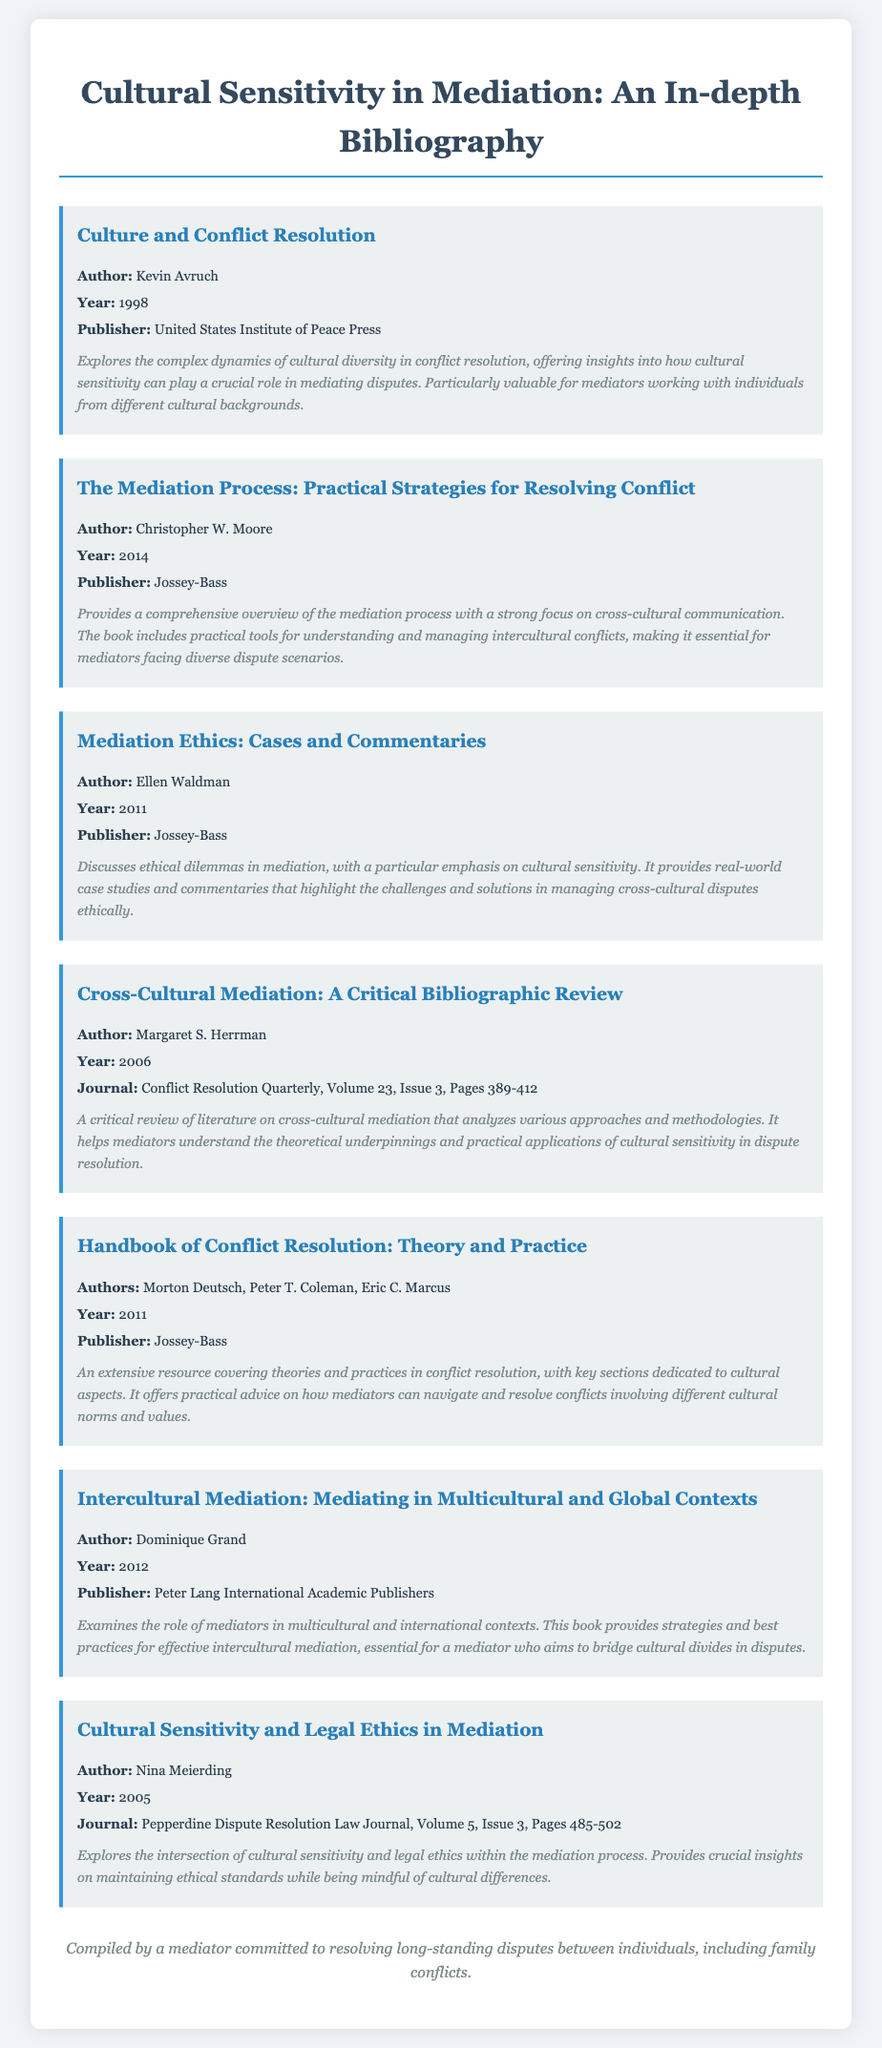what is the title of the bibliography? The title is prominently displayed at the top of the document and states the focus on cultural sensitivity in mediation.
Answer: Cultural Sensitivity in Mediation: An In-depth Bibliography who authored "Culture and Conflict Resolution"? This is a specific detail found in the bibliography item for that work, noting the author’s name.
Answer: Kevin Avruch what year was "The Mediation Process: Practical Strategies for Resolving Conflict" published? The publication year is clearly mentioned in the entry, providing a specific date relevant to the book.
Answer: 2014 which publisher released "Mediation Ethics: Cases and Commentaries"? The name of the publisher is indicated in the bibliography entry for the cited work.
Answer: Jossey-Bass how many authors wrote "Handbook of Conflict Resolution: Theory and Practice"? The entry specifies the number of authors involved in this publication, which is significant in understanding its collective perspective.
Answer: Three what focused area does "Intercultural Mediation: Mediating in Multicultural and Global Contexts" address? The description of the book highlights its major theme regarding the context of mediation it covers.
Answer: Multicultural and international contexts which journal published "Cultural Sensitivity and Legal Ethics in Mediation"? The source of the article is mentioned, indicating where it can be found in academic literature.
Answer: Pepperdine Dispute Resolution Law Journal what is the primary theme of the bibliography? The overarching theme of the bibliography is inferred from the title and various entries listed throughout the document.
Answer: Cultural sensitivity in mediation what does the mediator note emphasize? The note at the bottom provides insight into the mediator's objective as elaborated in the concluding remark of the document.
Answer: Resolving long-standing disputes between individuals 